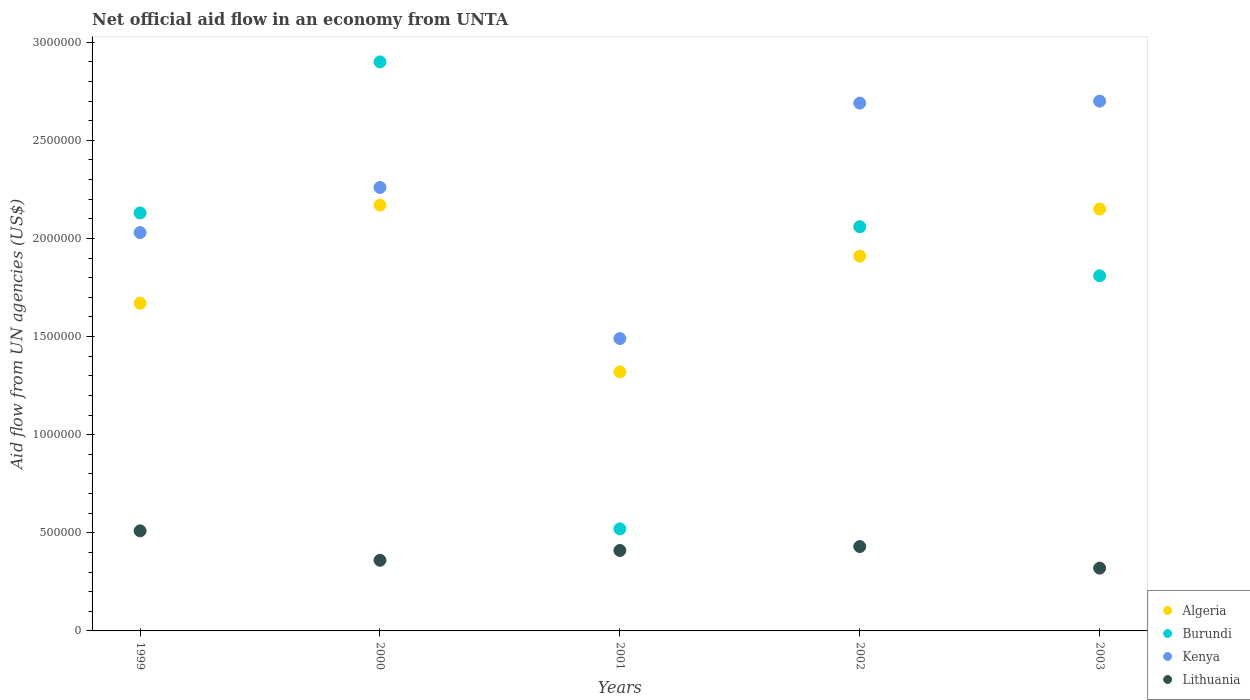What is the net official aid flow in Kenya in 2000?
Provide a succinct answer. 2.26e+06. Across all years, what is the maximum net official aid flow in Burundi?
Keep it short and to the point. 2.90e+06. Across all years, what is the minimum net official aid flow in Algeria?
Your response must be concise. 1.32e+06. In which year was the net official aid flow in Lithuania minimum?
Offer a very short reply. 2003. What is the total net official aid flow in Algeria in the graph?
Make the answer very short. 9.22e+06. What is the difference between the net official aid flow in Lithuania in 1999 and the net official aid flow in Algeria in 2000?
Ensure brevity in your answer.  -1.66e+06. What is the average net official aid flow in Kenya per year?
Make the answer very short. 2.23e+06. In the year 1999, what is the difference between the net official aid flow in Algeria and net official aid flow in Burundi?
Your response must be concise. -4.60e+05. What is the ratio of the net official aid flow in Kenya in 2002 to that in 2003?
Make the answer very short. 1. Is the net official aid flow in Burundi in 2001 less than that in 2003?
Provide a short and direct response. Yes. What is the difference between the highest and the second highest net official aid flow in Burundi?
Ensure brevity in your answer.  7.70e+05. What is the difference between the highest and the lowest net official aid flow in Algeria?
Provide a succinct answer. 8.50e+05. Is it the case that in every year, the sum of the net official aid flow in Lithuania and net official aid flow in Kenya  is greater than the sum of net official aid flow in Algeria and net official aid flow in Burundi?
Your answer should be very brief. No. Is it the case that in every year, the sum of the net official aid flow in Lithuania and net official aid flow in Burundi  is greater than the net official aid flow in Kenya?
Offer a very short reply. No. Does the net official aid flow in Algeria monotonically increase over the years?
Your response must be concise. No. Is the net official aid flow in Lithuania strictly greater than the net official aid flow in Burundi over the years?
Give a very brief answer. No. How many dotlines are there?
Your response must be concise. 4. What is the difference between two consecutive major ticks on the Y-axis?
Give a very brief answer. 5.00e+05. Are the values on the major ticks of Y-axis written in scientific E-notation?
Your answer should be very brief. No. Where does the legend appear in the graph?
Give a very brief answer. Bottom right. How many legend labels are there?
Provide a succinct answer. 4. What is the title of the graph?
Offer a terse response. Net official aid flow in an economy from UNTA. Does "Upper middle income" appear as one of the legend labels in the graph?
Offer a very short reply. No. What is the label or title of the Y-axis?
Ensure brevity in your answer.  Aid flow from UN agencies (US$). What is the Aid flow from UN agencies (US$) of Algeria in 1999?
Your answer should be compact. 1.67e+06. What is the Aid flow from UN agencies (US$) in Burundi in 1999?
Ensure brevity in your answer.  2.13e+06. What is the Aid flow from UN agencies (US$) in Kenya in 1999?
Your answer should be compact. 2.03e+06. What is the Aid flow from UN agencies (US$) of Lithuania in 1999?
Your answer should be compact. 5.10e+05. What is the Aid flow from UN agencies (US$) of Algeria in 2000?
Make the answer very short. 2.17e+06. What is the Aid flow from UN agencies (US$) in Burundi in 2000?
Your response must be concise. 2.90e+06. What is the Aid flow from UN agencies (US$) of Kenya in 2000?
Keep it short and to the point. 2.26e+06. What is the Aid flow from UN agencies (US$) in Algeria in 2001?
Give a very brief answer. 1.32e+06. What is the Aid flow from UN agencies (US$) in Burundi in 2001?
Offer a terse response. 5.20e+05. What is the Aid flow from UN agencies (US$) of Kenya in 2001?
Make the answer very short. 1.49e+06. What is the Aid flow from UN agencies (US$) of Algeria in 2002?
Provide a short and direct response. 1.91e+06. What is the Aid flow from UN agencies (US$) of Burundi in 2002?
Provide a succinct answer. 2.06e+06. What is the Aid flow from UN agencies (US$) in Kenya in 2002?
Your answer should be very brief. 2.69e+06. What is the Aid flow from UN agencies (US$) in Lithuania in 2002?
Offer a terse response. 4.30e+05. What is the Aid flow from UN agencies (US$) in Algeria in 2003?
Provide a succinct answer. 2.15e+06. What is the Aid flow from UN agencies (US$) of Burundi in 2003?
Provide a succinct answer. 1.81e+06. What is the Aid flow from UN agencies (US$) in Kenya in 2003?
Your answer should be very brief. 2.70e+06. Across all years, what is the maximum Aid flow from UN agencies (US$) in Algeria?
Ensure brevity in your answer.  2.17e+06. Across all years, what is the maximum Aid flow from UN agencies (US$) of Burundi?
Offer a terse response. 2.90e+06. Across all years, what is the maximum Aid flow from UN agencies (US$) of Kenya?
Make the answer very short. 2.70e+06. Across all years, what is the maximum Aid flow from UN agencies (US$) of Lithuania?
Keep it short and to the point. 5.10e+05. Across all years, what is the minimum Aid flow from UN agencies (US$) of Algeria?
Your answer should be very brief. 1.32e+06. Across all years, what is the minimum Aid flow from UN agencies (US$) of Burundi?
Give a very brief answer. 5.20e+05. Across all years, what is the minimum Aid flow from UN agencies (US$) in Kenya?
Offer a terse response. 1.49e+06. Across all years, what is the minimum Aid flow from UN agencies (US$) of Lithuania?
Offer a terse response. 3.20e+05. What is the total Aid flow from UN agencies (US$) of Algeria in the graph?
Offer a terse response. 9.22e+06. What is the total Aid flow from UN agencies (US$) in Burundi in the graph?
Ensure brevity in your answer.  9.42e+06. What is the total Aid flow from UN agencies (US$) of Kenya in the graph?
Your answer should be compact. 1.12e+07. What is the total Aid flow from UN agencies (US$) in Lithuania in the graph?
Provide a short and direct response. 2.03e+06. What is the difference between the Aid flow from UN agencies (US$) of Algeria in 1999 and that in 2000?
Make the answer very short. -5.00e+05. What is the difference between the Aid flow from UN agencies (US$) of Burundi in 1999 and that in 2000?
Your response must be concise. -7.70e+05. What is the difference between the Aid flow from UN agencies (US$) in Lithuania in 1999 and that in 2000?
Your answer should be compact. 1.50e+05. What is the difference between the Aid flow from UN agencies (US$) of Algeria in 1999 and that in 2001?
Your response must be concise. 3.50e+05. What is the difference between the Aid flow from UN agencies (US$) of Burundi in 1999 and that in 2001?
Offer a very short reply. 1.61e+06. What is the difference between the Aid flow from UN agencies (US$) of Kenya in 1999 and that in 2001?
Provide a short and direct response. 5.40e+05. What is the difference between the Aid flow from UN agencies (US$) in Kenya in 1999 and that in 2002?
Provide a succinct answer. -6.60e+05. What is the difference between the Aid flow from UN agencies (US$) of Algeria in 1999 and that in 2003?
Offer a very short reply. -4.80e+05. What is the difference between the Aid flow from UN agencies (US$) of Kenya in 1999 and that in 2003?
Keep it short and to the point. -6.70e+05. What is the difference between the Aid flow from UN agencies (US$) of Lithuania in 1999 and that in 2003?
Provide a succinct answer. 1.90e+05. What is the difference between the Aid flow from UN agencies (US$) of Algeria in 2000 and that in 2001?
Offer a terse response. 8.50e+05. What is the difference between the Aid flow from UN agencies (US$) in Burundi in 2000 and that in 2001?
Give a very brief answer. 2.38e+06. What is the difference between the Aid flow from UN agencies (US$) in Kenya in 2000 and that in 2001?
Offer a very short reply. 7.70e+05. What is the difference between the Aid flow from UN agencies (US$) in Burundi in 2000 and that in 2002?
Provide a short and direct response. 8.40e+05. What is the difference between the Aid flow from UN agencies (US$) in Kenya in 2000 and that in 2002?
Make the answer very short. -4.30e+05. What is the difference between the Aid flow from UN agencies (US$) of Lithuania in 2000 and that in 2002?
Offer a very short reply. -7.00e+04. What is the difference between the Aid flow from UN agencies (US$) in Burundi in 2000 and that in 2003?
Provide a short and direct response. 1.09e+06. What is the difference between the Aid flow from UN agencies (US$) of Kenya in 2000 and that in 2003?
Your answer should be compact. -4.40e+05. What is the difference between the Aid flow from UN agencies (US$) of Algeria in 2001 and that in 2002?
Offer a very short reply. -5.90e+05. What is the difference between the Aid flow from UN agencies (US$) in Burundi in 2001 and that in 2002?
Provide a short and direct response. -1.54e+06. What is the difference between the Aid flow from UN agencies (US$) in Kenya in 2001 and that in 2002?
Offer a terse response. -1.20e+06. What is the difference between the Aid flow from UN agencies (US$) of Algeria in 2001 and that in 2003?
Offer a terse response. -8.30e+05. What is the difference between the Aid flow from UN agencies (US$) of Burundi in 2001 and that in 2003?
Offer a terse response. -1.29e+06. What is the difference between the Aid flow from UN agencies (US$) of Kenya in 2001 and that in 2003?
Your response must be concise. -1.21e+06. What is the difference between the Aid flow from UN agencies (US$) in Algeria in 2002 and that in 2003?
Offer a terse response. -2.40e+05. What is the difference between the Aid flow from UN agencies (US$) of Kenya in 2002 and that in 2003?
Provide a short and direct response. -10000. What is the difference between the Aid flow from UN agencies (US$) in Lithuania in 2002 and that in 2003?
Your response must be concise. 1.10e+05. What is the difference between the Aid flow from UN agencies (US$) of Algeria in 1999 and the Aid flow from UN agencies (US$) of Burundi in 2000?
Give a very brief answer. -1.23e+06. What is the difference between the Aid flow from UN agencies (US$) of Algeria in 1999 and the Aid flow from UN agencies (US$) of Kenya in 2000?
Keep it short and to the point. -5.90e+05. What is the difference between the Aid flow from UN agencies (US$) of Algeria in 1999 and the Aid flow from UN agencies (US$) of Lithuania in 2000?
Provide a succinct answer. 1.31e+06. What is the difference between the Aid flow from UN agencies (US$) of Burundi in 1999 and the Aid flow from UN agencies (US$) of Lithuania in 2000?
Your answer should be very brief. 1.77e+06. What is the difference between the Aid flow from UN agencies (US$) of Kenya in 1999 and the Aid flow from UN agencies (US$) of Lithuania in 2000?
Provide a succinct answer. 1.67e+06. What is the difference between the Aid flow from UN agencies (US$) in Algeria in 1999 and the Aid flow from UN agencies (US$) in Burundi in 2001?
Make the answer very short. 1.15e+06. What is the difference between the Aid flow from UN agencies (US$) of Algeria in 1999 and the Aid flow from UN agencies (US$) of Lithuania in 2001?
Give a very brief answer. 1.26e+06. What is the difference between the Aid flow from UN agencies (US$) of Burundi in 1999 and the Aid flow from UN agencies (US$) of Kenya in 2001?
Make the answer very short. 6.40e+05. What is the difference between the Aid flow from UN agencies (US$) of Burundi in 1999 and the Aid flow from UN agencies (US$) of Lithuania in 2001?
Provide a succinct answer. 1.72e+06. What is the difference between the Aid flow from UN agencies (US$) in Kenya in 1999 and the Aid flow from UN agencies (US$) in Lithuania in 2001?
Make the answer very short. 1.62e+06. What is the difference between the Aid flow from UN agencies (US$) in Algeria in 1999 and the Aid flow from UN agencies (US$) in Burundi in 2002?
Provide a short and direct response. -3.90e+05. What is the difference between the Aid flow from UN agencies (US$) in Algeria in 1999 and the Aid flow from UN agencies (US$) in Kenya in 2002?
Make the answer very short. -1.02e+06. What is the difference between the Aid flow from UN agencies (US$) of Algeria in 1999 and the Aid flow from UN agencies (US$) of Lithuania in 2002?
Your answer should be very brief. 1.24e+06. What is the difference between the Aid flow from UN agencies (US$) of Burundi in 1999 and the Aid flow from UN agencies (US$) of Kenya in 2002?
Offer a very short reply. -5.60e+05. What is the difference between the Aid flow from UN agencies (US$) in Burundi in 1999 and the Aid flow from UN agencies (US$) in Lithuania in 2002?
Ensure brevity in your answer.  1.70e+06. What is the difference between the Aid flow from UN agencies (US$) of Kenya in 1999 and the Aid flow from UN agencies (US$) of Lithuania in 2002?
Keep it short and to the point. 1.60e+06. What is the difference between the Aid flow from UN agencies (US$) of Algeria in 1999 and the Aid flow from UN agencies (US$) of Burundi in 2003?
Provide a short and direct response. -1.40e+05. What is the difference between the Aid flow from UN agencies (US$) in Algeria in 1999 and the Aid flow from UN agencies (US$) in Kenya in 2003?
Offer a terse response. -1.03e+06. What is the difference between the Aid flow from UN agencies (US$) in Algeria in 1999 and the Aid flow from UN agencies (US$) in Lithuania in 2003?
Make the answer very short. 1.35e+06. What is the difference between the Aid flow from UN agencies (US$) of Burundi in 1999 and the Aid flow from UN agencies (US$) of Kenya in 2003?
Offer a terse response. -5.70e+05. What is the difference between the Aid flow from UN agencies (US$) in Burundi in 1999 and the Aid flow from UN agencies (US$) in Lithuania in 2003?
Offer a terse response. 1.81e+06. What is the difference between the Aid flow from UN agencies (US$) of Kenya in 1999 and the Aid flow from UN agencies (US$) of Lithuania in 2003?
Provide a short and direct response. 1.71e+06. What is the difference between the Aid flow from UN agencies (US$) in Algeria in 2000 and the Aid flow from UN agencies (US$) in Burundi in 2001?
Give a very brief answer. 1.65e+06. What is the difference between the Aid flow from UN agencies (US$) in Algeria in 2000 and the Aid flow from UN agencies (US$) in Kenya in 2001?
Provide a succinct answer. 6.80e+05. What is the difference between the Aid flow from UN agencies (US$) in Algeria in 2000 and the Aid flow from UN agencies (US$) in Lithuania in 2001?
Give a very brief answer. 1.76e+06. What is the difference between the Aid flow from UN agencies (US$) in Burundi in 2000 and the Aid flow from UN agencies (US$) in Kenya in 2001?
Your response must be concise. 1.41e+06. What is the difference between the Aid flow from UN agencies (US$) of Burundi in 2000 and the Aid flow from UN agencies (US$) of Lithuania in 2001?
Your response must be concise. 2.49e+06. What is the difference between the Aid flow from UN agencies (US$) in Kenya in 2000 and the Aid flow from UN agencies (US$) in Lithuania in 2001?
Provide a succinct answer. 1.85e+06. What is the difference between the Aid flow from UN agencies (US$) in Algeria in 2000 and the Aid flow from UN agencies (US$) in Kenya in 2002?
Provide a succinct answer. -5.20e+05. What is the difference between the Aid flow from UN agencies (US$) in Algeria in 2000 and the Aid flow from UN agencies (US$) in Lithuania in 2002?
Your answer should be very brief. 1.74e+06. What is the difference between the Aid flow from UN agencies (US$) of Burundi in 2000 and the Aid flow from UN agencies (US$) of Lithuania in 2002?
Offer a terse response. 2.47e+06. What is the difference between the Aid flow from UN agencies (US$) in Kenya in 2000 and the Aid flow from UN agencies (US$) in Lithuania in 2002?
Keep it short and to the point. 1.83e+06. What is the difference between the Aid flow from UN agencies (US$) of Algeria in 2000 and the Aid flow from UN agencies (US$) of Kenya in 2003?
Offer a terse response. -5.30e+05. What is the difference between the Aid flow from UN agencies (US$) of Algeria in 2000 and the Aid flow from UN agencies (US$) of Lithuania in 2003?
Your answer should be compact. 1.85e+06. What is the difference between the Aid flow from UN agencies (US$) of Burundi in 2000 and the Aid flow from UN agencies (US$) of Lithuania in 2003?
Your answer should be compact. 2.58e+06. What is the difference between the Aid flow from UN agencies (US$) in Kenya in 2000 and the Aid flow from UN agencies (US$) in Lithuania in 2003?
Make the answer very short. 1.94e+06. What is the difference between the Aid flow from UN agencies (US$) of Algeria in 2001 and the Aid flow from UN agencies (US$) of Burundi in 2002?
Your response must be concise. -7.40e+05. What is the difference between the Aid flow from UN agencies (US$) of Algeria in 2001 and the Aid flow from UN agencies (US$) of Kenya in 2002?
Give a very brief answer. -1.37e+06. What is the difference between the Aid flow from UN agencies (US$) of Algeria in 2001 and the Aid flow from UN agencies (US$) of Lithuania in 2002?
Your answer should be compact. 8.90e+05. What is the difference between the Aid flow from UN agencies (US$) of Burundi in 2001 and the Aid flow from UN agencies (US$) of Kenya in 2002?
Give a very brief answer. -2.17e+06. What is the difference between the Aid flow from UN agencies (US$) of Kenya in 2001 and the Aid flow from UN agencies (US$) of Lithuania in 2002?
Your answer should be very brief. 1.06e+06. What is the difference between the Aid flow from UN agencies (US$) of Algeria in 2001 and the Aid flow from UN agencies (US$) of Burundi in 2003?
Make the answer very short. -4.90e+05. What is the difference between the Aid flow from UN agencies (US$) of Algeria in 2001 and the Aid flow from UN agencies (US$) of Kenya in 2003?
Your answer should be very brief. -1.38e+06. What is the difference between the Aid flow from UN agencies (US$) of Burundi in 2001 and the Aid flow from UN agencies (US$) of Kenya in 2003?
Provide a short and direct response. -2.18e+06. What is the difference between the Aid flow from UN agencies (US$) in Kenya in 2001 and the Aid flow from UN agencies (US$) in Lithuania in 2003?
Give a very brief answer. 1.17e+06. What is the difference between the Aid flow from UN agencies (US$) in Algeria in 2002 and the Aid flow from UN agencies (US$) in Kenya in 2003?
Ensure brevity in your answer.  -7.90e+05. What is the difference between the Aid flow from UN agencies (US$) of Algeria in 2002 and the Aid flow from UN agencies (US$) of Lithuania in 2003?
Give a very brief answer. 1.59e+06. What is the difference between the Aid flow from UN agencies (US$) of Burundi in 2002 and the Aid flow from UN agencies (US$) of Kenya in 2003?
Offer a terse response. -6.40e+05. What is the difference between the Aid flow from UN agencies (US$) in Burundi in 2002 and the Aid flow from UN agencies (US$) in Lithuania in 2003?
Provide a succinct answer. 1.74e+06. What is the difference between the Aid flow from UN agencies (US$) in Kenya in 2002 and the Aid flow from UN agencies (US$) in Lithuania in 2003?
Offer a very short reply. 2.37e+06. What is the average Aid flow from UN agencies (US$) in Algeria per year?
Offer a terse response. 1.84e+06. What is the average Aid flow from UN agencies (US$) of Burundi per year?
Your answer should be very brief. 1.88e+06. What is the average Aid flow from UN agencies (US$) of Kenya per year?
Make the answer very short. 2.23e+06. What is the average Aid flow from UN agencies (US$) of Lithuania per year?
Provide a short and direct response. 4.06e+05. In the year 1999, what is the difference between the Aid flow from UN agencies (US$) in Algeria and Aid flow from UN agencies (US$) in Burundi?
Give a very brief answer. -4.60e+05. In the year 1999, what is the difference between the Aid flow from UN agencies (US$) of Algeria and Aid flow from UN agencies (US$) of Kenya?
Give a very brief answer. -3.60e+05. In the year 1999, what is the difference between the Aid flow from UN agencies (US$) in Algeria and Aid flow from UN agencies (US$) in Lithuania?
Keep it short and to the point. 1.16e+06. In the year 1999, what is the difference between the Aid flow from UN agencies (US$) in Burundi and Aid flow from UN agencies (US$) in Kenya?
Keep it short and to the point. 1.00e+05. In the year 1999, what is the difference between the Aid flow from UN agencies (US$) of Burundi and Aid flow from UN agencies (US$) of Lithuania?
Provide a short and direct response. 1.62e+06. In the year 1999, what is the difference between the Aid flow from UN agencies (US$) in Kenya and Aid flow from UN agencies (US$) in Lithuania?
Keep it short and to the point. 1.52e+06. In the year 2000, what is the difference between the Aid flow from UN agencies (US$) in Algeria and Aid flow from UN agencies (US$) in Burundi?
Keep it short and to the point. -7.30e+05. In the year 2000, what is the difference between the Aid flow from UN agencies (US$) of Algeria and Aid flow from UN agencies (US$) of Kenya?
Offer a terse response. -9.00e+04. In the year 2000, what is the difference between the Aid flow from UN agencies (US$) of Algeria and Aid flow from UN agencies (US$) of Lithuania?
Provide a short and direct response. 1.81e+06. In the year 2000, what is the difference between the Aid flow from UN agencies (US$) of Burundi and Aid flow from UN agencies (US$) of Kenya?
Your response must be concise. 6.40e+05. In the year 2000, what is the difference between the Aid flow from UN agencies (US$) of Burundi and Aid flow from UN agencies (US$) of Lithuania?
Provide a succinct answer. 2.54e+06. In the year 2000, what is the difference between the Aid flow from UN agencies (US$) in Kenya and Aid flow from UN agencies (US$) in Lithuania?
Provide a succinct answer. 1.90e+06. In the year 2001, what is the difference between the Aid flow from UN agencies (US$) of Algeria and Aid flow from UN agencies (US$) of Kenya?
Keep it short and to the point. -1.70e+05. In the year 2001, what is the difference between the Aid flow from UN agencies (US$) in Algeria and Aid flow from UN agencies (US$) in Lithuania?
Provide a succinct answer. 9.10e+05. In the year 2001, what is the difference between the Aid flow from UN agencies (US$) in Burundi and Aid flow from UN agencies (US$) in Kenya?
Offer a very short reply. -9.70e+05. In the year 2001, what is the difference between the Aid flow from UN agencies (US$) in Kenya and Aid flow from UN agencies (US$) in Lithuania?
Provide a short and direct response. 1.08e+06. In the year 2002, what is the difference between the Aid flow from UN agencies (US$) of Algeria and Aid flow from UN agencies (US$) of Burundi?
Give a very brief answer. -1.50e+05. In the year 2002, what is the difference between the Aid flow from UN agencies (US$) of Algeria and Aid flow from UN agencies (US$) of Kenya?
Offer a terse response. -7.80e+05. In the year 2002, what is the difference between the Aid flow from UN agencies (US$) in Algeria and Aid flow from UN agencies (US$) in Lithuania?
Your response must be concise. 1.48e+06. In the year 2002, what is the difference between the Aid flow from UN agencies (US$) in Burundi and Aid flow from UN agencies (US$) in Kenya?
Your response must be concise. -6.30e+05. In the year 2002, what is the difference between the Aid flow from UN agencies (US$) in Burundi and Aid flow from UN agencies (US$) in Lithuania?
Your answer should be compact. 1.63e+06. In the year 2002, what is the difference between the Aid flow from UN agencies (US$) in Kenya and Aid flow from UN agencies (US$) in Lithuania?
Ensure brevity in your answer.  2.26e+06. In the year 2003, what is the difference between the Aid flow from UN agencies (US$) in Algeria and Aid flow from UN agencies (US$) in Kenya?
Your answer should be very brief. -5.50e+05. In the year 2003, what is the difference between the Aid flow from UN agencies (US$) of Algeria and Aid flow from UN agencies (US$) of Lithuania?
Provide a succinct answer. 1.83e+06. In the year 2003, what is the difference between the Aid flow from UN agencies (US$) in Burundi and Aid flow from UN agencies (US$) in Kenya?
Give a very brief answer. -8.90e+05. In the year 2003, what is the difference between the Aid flow from UN agencies (US$) of Burundi and Aid flow from UN agencies (US$) of Lithuania?
Give a very brief answer. 1.49e+06. In the year 2003, what is the difference between the Aid flow from UN agencies (US$) of Kenya and Aid flow from UN agencies (US$) of Lithuania?
Give a very brief answer. 2.38e+06. What is the ratio of the Aid flow from UN agencies (US$) of Algeria in 1999 to that in 2000?
Your response must be concise. 0.77. What is the ratio of the Aid flow from UN agencies (US$) of Burundi in 1999 to that in 2000?
Your answer should be very brief. 0.73. What is the ratio of the Aid flow from UN agencies (US$) in Kenya in 1999 to that in 2000?
Offer a very short reply. 0.9. What is the ratio of the Aid flow from UN agencies (US$) of Lithuania in 1999 to that in 2000?
Provide a short and direct response. 1.42. What is the ratio of the Aid flow from UN agencies (US$) in Algeria in 1999 to that in 2001?
Provide a succinct answer. 1.27. What is the ratio of the Aid flow from UN agencies (US$) of Burundi in 1999 to that in 2001?
Your response must be concise. 4.1. What is the ratio of the Aid flow from UN agencies (US$) of Kenya in 1999 to that in 2001?
Your answer should be very brief. 1.36. What is the ratio of the Aid flow from UN agencies (US$) of Lithuania in 1999 to that in 2001?
Offer a very short reply. 1.24. What is the ratio of the Aid flow from UN agencies (US$) of Algeria in 1999 to that in 2002?
Offer a very short reply. 0.87. What is the ratio of the Aid flow from UN agencies (US$) of Burundi in 1999 to that in 2002?
Keep it short and to the point. 1.03. What is the ratio of the Aid flow from UN agencies (US$) of Kenya in 1999 to that in 2002?
Your answer should be compact. 0.75. What is the ratio of the Aid flow from UN agencies (US$) in Lithuania in 1999 to that in 2002?
Offer a very short reply. 1.19. What is the ratio of the Aid flow from UN agencies (US$) of Algeria in 1999 to that in 2003?
Ensure brevity in your answer.  0.78. What is the ratio of the Aid flow from UN agencies (US$) of Burundi in 1999 to that in 2003?
Your response must be concise. 1.18. What is the ratio of the Aid flow from UN agencies (US$) of Kenya in 1999 to that in 2003?
Provide a succinct answer. 0.75. What is the ratio of the Aid flow from UN agencies (US$) of Lithuania in 1999 to that in 2003?
Offer a terse response. 1.59. What is the ratio of the Aid flow from UN agencies (US$) in Algeria in 2000 to that in 2001?
Your answer should be compact. 1.64. What is the ratio of the Aid flow from UN agencies (US$) in Burundi in 2000 to that in 2001?
Your answer should be very brief. 5.58. What is the ratio of the Aid flow from UN agencies (US$) of Kenya in 2000 to that in 2001?
Keep it short and to the point. 1.52. What is the ratio of the Aid flow from UN agencies (US$) in Lithuania in 2000 to that in 2001?
Provide a succinct answer. 0.88. What is the ratio of the Aid flow from UN agencies (US$) of Algeria in 2000 to that in 2002?
Your response must be concise. 1.14. What is the ratio of the Aid flow from UN agencies (US$) in Burundi in 2000 to that in 2002?
Your response must be concise. 1.41. What is the ratio of the Aid flow from UN agencies (US$) in Kenya in 2000 to that in 2002?
Your answer should be compact. 0.84. What is the ratio of the Aid flow from UN agencies (US$) of Lithuania in 2000 to that in 2002?
Offer a very short reply. 0.84. What is the ratio of the Aid flow from UN agencies (US$) in Algeria in 2000 to that in 2003?
Offer a very short reply. 1.01. What is the ratio of the Aid flow from UN agencies (US$) of Burundi in 2000 to that in 2003?
Provide a succinct answer. 1.6. What is the ratio of the Aid flow from UN agencies (US$) of Kenya in 2000 to that in 2003?
Provide a short and direct response. 0.84. What is the ratio of the Aid flow from UN agencies (US$) in Lithuania in 2000 to that in 2003?
Give a very brief answer. 1.12. What is the ratio of the Aid flow from UN agencies (US$) of Algeria in 2001 to that in 2002?
Give a very brief answer. 0.69. What is the ratio of the Aid flow from UN agencies (US$) in Burundi in 2001 to that in 2002?
Provide a succinct answer. 0.25. What is the ratio of the Aid flow from UN agencies (US$) of Kenya in 2001 to that in 2002?
Make the answer very short. 0.55. What is the ratio of the Aid flow from UN agencies (US$) in Lithuania in 2001 to that in 2002?
Ensure brevity in your answer.  0.95. What is the ratio of the Aid flow from UN agencies (US$) in Algeria in 2001 to that in 2003?
Your answer should be compact. 0.61. What is the ratio of the Aid flow from UN agencies (US$) of Burundi in 2001 to that in 2003?
Give a very brief answer. 0.29. What is the ratio of the Aid flow from UN agencies (US$) in Kenya in 2001 to that in 2003?
Provide a short and direct response. 0.55. What is the ratio of the Aid flow from UN agencies (US$) in Lithuania in 2001 to that in 2003?
Make the answer very short. 1.28. What is the ratio of the Aid flow from UN agencies (US$) of Algeria in 2002 to that in 2003?
Keep it short and to the point. 0.89. What is the ratio of the Aid flow from UN agencies (US$) of Burundi in 2002 to that in 2003?
Provide a succinct answer. 1.14. What is the ratio of the Aid flow from UN agencies (US$) of Lithuania in 2002 to that in 2003?
Provide a succinct answer. 1.34. What is the difference between the highest and the second highest Aid flow from UN agencies (US$) of Burundi?
Make the answer very short. 7.70e+05. What is the difference between the highest and the second highest Aid flow from UN agencies (US$) of Kenya?
Your response must be concise. 10000. What is the difference between the highest and the second highest Aid flow from UN agencies (US$) of Lithuania?
Offer a very short reply. 8.00e+04. What is the difference between the highest and the lowest Aid flow from UN agencies (US$) in Algeria?
Your answer should be compact. 8.50e+05. What is the difference between the highest and the lowest Aid flow from UN agencies (US$) in Burundi?
Keep it short and to the point. 2.38e+06. What is the difference between the highest and the lowest Aid flow from UN agencies (US$) in Kenya?
Give a very brief answer. 1.21e+06. What is the difference between the highest and the lowest Aid flow from UN agencies (US$) in Lithuania?
Give a very brief answer. 1.90e+05. 